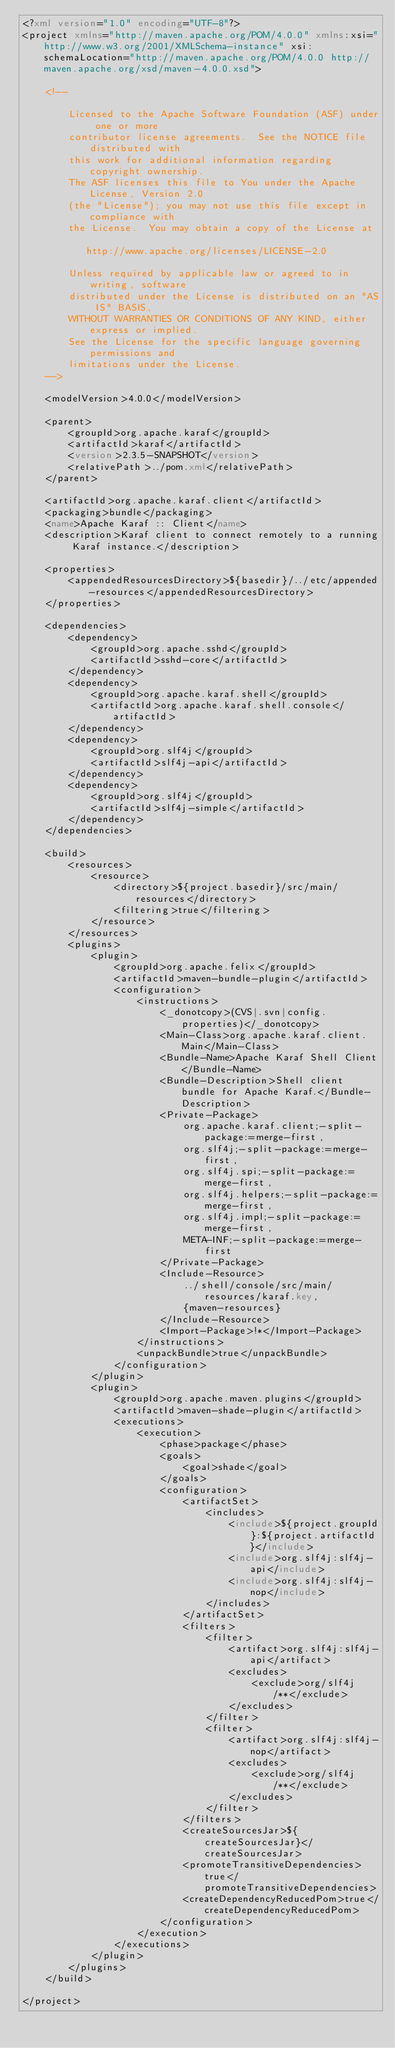Convert code to text. <code><loc_0><loc_0><loc_500><loc_500><_XML_><?xml version="1.0" encoding="UTF-8"?>
<project xmlns="http://maven.apache.org/POM/4.0.0" xmlns:xsi="http://www.w3.org/2001/XMLSchema-instance" xsi:schemaLocation="http://maven.apache.org/POM/4.0.0 http://maven.apache.org/xsd/maven-4.0.0.xsd">

    <!--

        Licensed to the Apache Software Foundation (ASF) under one or more
        contributor license agreements.  See the NOTICE file distributed with
        this work for additional information regarding copyright ownership.
        The ASF licenses this file to You under the Apache License, Version 2.0
        (the "License"); you may not use this file except in compliance with
        the License.  You may obtain a copy of the License at

           http://www.apache.org/licenses/LICENSE-2.0

        Unless required by applicable law or agreed to in writing, software
        distributed under the License is distributed on an "AS IS" BASIS,
        WITHOUT WARRANTIES OR CONDITIONS OF ANY KIND, either express or implied.
        See the License for the specific language governing permissions and
        limitations under the License.
    -->

    <modelVersion>4.0.0</modelVersion>

    <parent>
        <groupId>org.apache.karaf</groupId>
        <artifactId>karaf</artifactId>
        <version>2.3.5-SNAPSHOT</version>
        <relativePath>../pom.xml</relativePath>
    </parent>

    <artifactId>org.apache.karaf.client</artifactId>
    <packaging>bundle</packaging>
    <name>Apache Karaf :: Client</name>
    <description>Karaf client to connect remotely to a running Karaf instance.</description>

    <properties>
        <appendedResourcesDirectory>${basedir}/../etc/appended-resources</appendedResourcesDirectory>
    </properties>

    <dependencies>
        <dependency>
            <groupId>org.apache.sshd</groupId>
            <artifactId>sshd-core</artifactId>
        </dependency>
        <dependency>
            <groupId>org.apache.karaf.shell</groupId>
            <artifactId>org.apache.karaf.shell.console</artifactId>
        </dependency>
        <dependency>
            <groupId>org.slf4j</groupId>
            <artifactId>slf4j-api</artifactId>
        </dependency>
        <dependency>
            <groupId>org.slf4j</groupId>
            <artifactId>slf4j-simple</artifactId>
        </dependency>
    </dependencies>

    <build>
        <resources>
            <resource>
                <directory>${project.basedir}/src/main/resources</directory>
                <filtering>true</filtering>
            </resource>
        </resources>
        <plugins>
            <plugin>
                <groupId>org.apache.felix</groupId>
                <artifactId>maven-bundle-plugin</artifactId>
                <configuration>
                    <instructions>
                        <_donotcopy>(CVS|.svn|config.properties)</_donotcopy>
                        <Main-Class>org.apache.karaf.client.Main</Main-Class>
                        <Bundle-Name>Apache Karaf Shell Client</Bundle-Name>
                        <Bundle-Description>Shell client bundle for Apache Karaf.</Bundle-Description>
                        <Private-Package>
                            org.apache.karaf.client;-split-package:=merge-first,
                            org.slf4j;-split-package:=merge-first,
                            org.slf4j.spi;-split-package:=merge-first,
                            org.slf4j.helpers;-split-package:=merge-first,
                            org.slf4j.impl;-split-package:=merge-first,
                            META-INF;-split-package:=merge-first
                        </Private-Package>
                        <Include-Resource>
                            ../shell/console/src/main/resources/karaf.key,
                            {maven-resources}
                        </Include-Resource>
                        <Import-Package>!*</Import-Package>
                    </instructions>
                    <unpackBundle>true</unpackBundle>
                </configuration>
            </plugin>
            <plugin>
                <groupId>org.apache.maven.plugins</groupId>
                <artifactId>maven-shade-plugin</artifactId>
                <executions>
                    <execution>
                        <phase>package</phase>
                        <goals>
                            <goal>shade</goal>
                        </goals>
                        <configuration>
                            <artifactSet>
                                <includes>
                                    <include>${project.groupId}:${project.artifactId}</include>
                                    <include>org.slf4j:slf4j-api</include>
                                    <include>org.slf4j:slf4j-nop</include>
                                </includes>
                            </artifactSet>
                            <filters>
                                <filter>
                                    <artifact>org.slf4j:slf4j-api</artifact>
                                    <excludes>
                                        <exclude>org/slf4j/**</exclude>
                                    </excludes>
                                </filter>
                                <filter>
                                    <artifact>org.slf4j:slf4j-nop</artifact>
                                    <excludes>
                                        <exclude>org/slf4j/**</exclude>
                                    </excludes>
                                </filter>
                            </filters>
                            <createSourcesJar>${createSourcesJar}</createSourcesJar>
                            <promoteTransitiveDependencies>true</promoteTransitiveDependencies>
                            <createDependencyReducedPom>true</createDependencyReducedPom>
                        </configuration>
                    </execution>
                </executions>
            </plugin>
        </plugins>
    </build>

</project>
</code> 